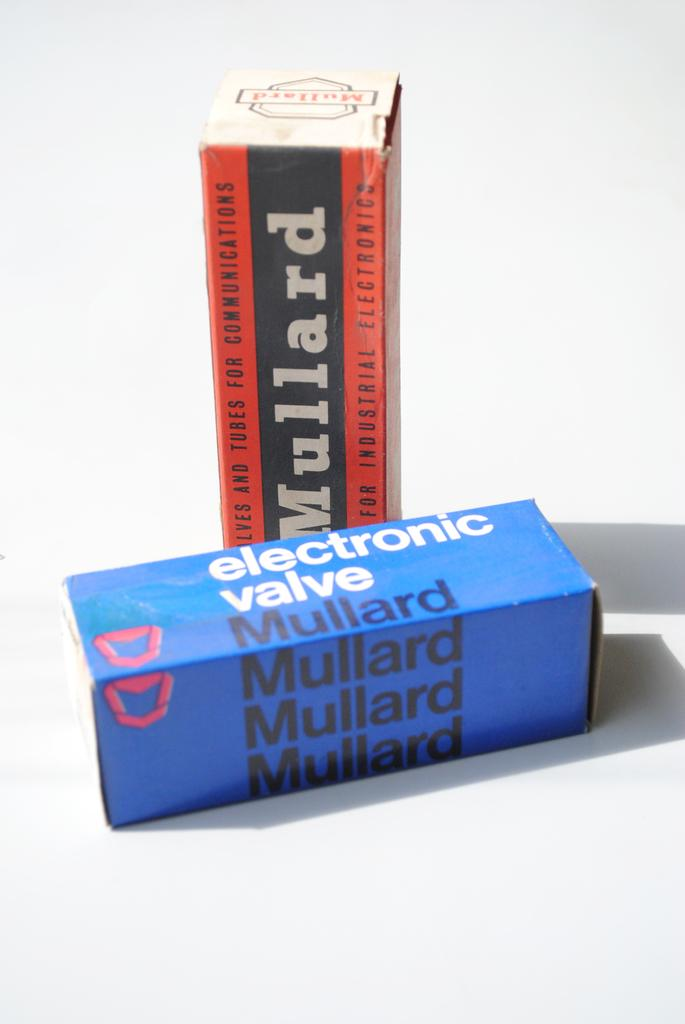<image>
Describe the image concisely. two boxes for Mullard electronics for valves and tubes 